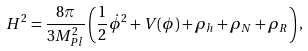Convert formula to latex. <formula><loc_0><loc_0><loc_500><loc_500>H ^ { 2 } = \frac { 8 \pi } { 3 M _ { P l } ^ { 2 } } \left ( \frac { 1 } { 2 } \dot { \phi } ^ { 2 } + V ( \phi ) + \rho _ { h } + \rho _ { N } + \rho _ { R } \right ) ,</formula> 